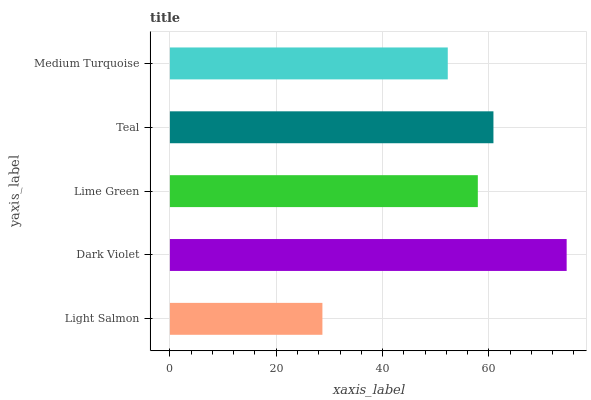Is Light Salmon the minimum?
Answer yes or no. Yes. Is Dark Violet the maximum?
Answer yes or no. Yes. Is Lime Green the minimum?
Answer yes or no. No. Is Lime Green the maximum?
Answer yes or no. No. Is Dark Violet greater than Lime Green?
Answer yes or no. Yes. Is Lime Green less than Dark Violet?
Answer yes or no. Yes. Is Lime Green greater than Dark Violet?
Answer yes or no. No. Is Dark Violet less than Lime Green?
Answer yes or no. No. Is Lime Green the high median?
Answer yes or no. Yes. Is Lime Green the low median?
Answer yes or no. Yes. Is Medium Turquoise the high median?
Answer yes or no. No. Is Light Salmon the low median?
Answer yes or no. No. 